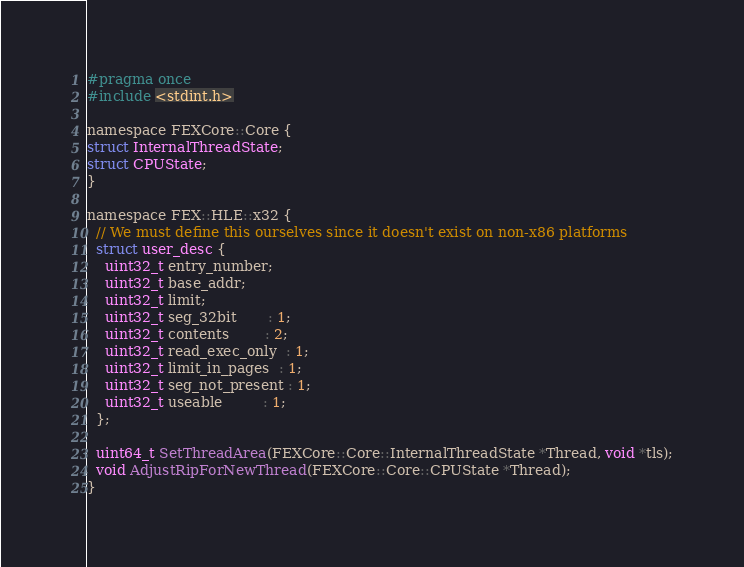Convert code to text. <code><loc_0><loc_0><loc_500><loc_500><_C_>#pragma once
#include <stdint.h>

namespace FEXCore::Core {
struct InternalThreadState;
struct CPUState;
}

namespace FEX::HLE::x32 {
  // We must define this ourselves since it doesn't exist on non-x86 platforms
  struct user_desc {
    uint32_t entry_number;
    uint32_t base_addr;
    uint32_t limit;
    uint32_t seg_32bit       : 1;
    uint32_t contents        : 2;
    uint32_t read_exec_only  : 1;
    uint32_t limit_in_pages  : 1;
    uint32_t seg_not_present : 1;
    uint32_t useable         : 1;
  };

  uint64_t SetThreadArea(FEXCore::Core::InternalThreadState *Thread, void *tls);
  void AdjustRipForNewThread(FEXCore::Core::CPUState *Thread);
}
</code> 